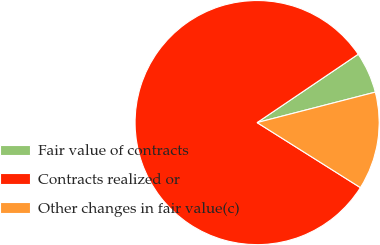Convert chart. <chart><loc_0><loc_0><loc_500><loc_500><pie_chart><fcel>Fair value of contracts<fcel>Contracts realized or<fcel>Other changes in fair value(c)<nl><fcel>5.45%<fcel>81.59%<fcel>12.96%<nl></chart> 